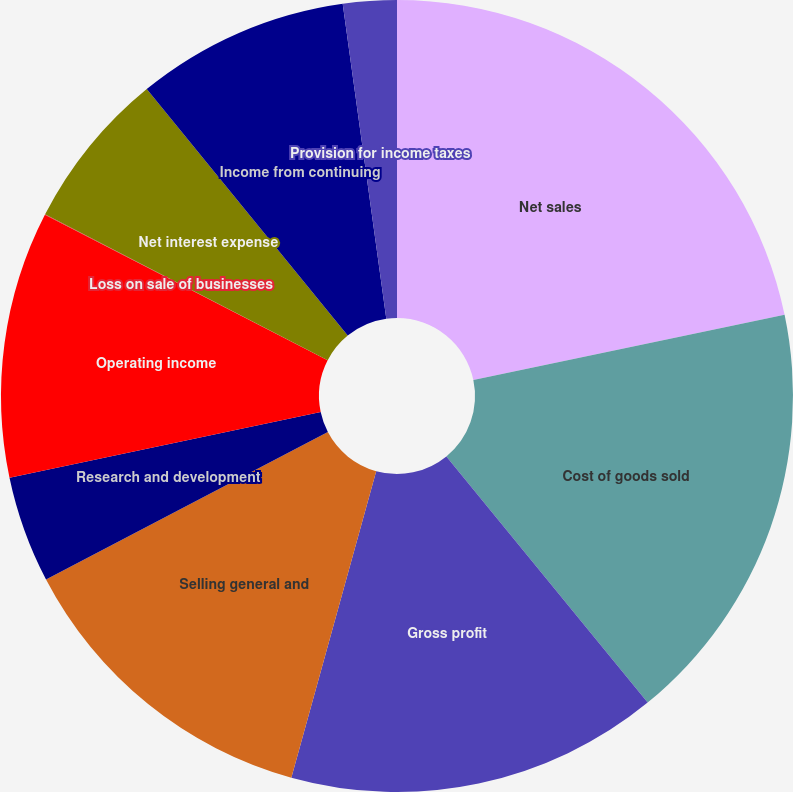Convert chart. <chart><loc_0><loc_0><loc_500><loc_500><pie_chart><fcel>Net sales<fcel>Cost of goods sold<fcel>Gross profit<fcel>Selling general and<fcel>Research and development<fcel>Operating income<fcel>Loss on sale of businesses<fcel>Net interest expense<fcel>Income from continuing<fcel>Provision for income taxes<nl><fcel>21.72%<fcel>17.38%<fcel>15.21%<fcel>13.04%<fcel>4.36%<fcel>10.87%<fcel>0.02%<fcel>6.53%<fcel>8.7%<fcel>2.19%<nl></chart> 